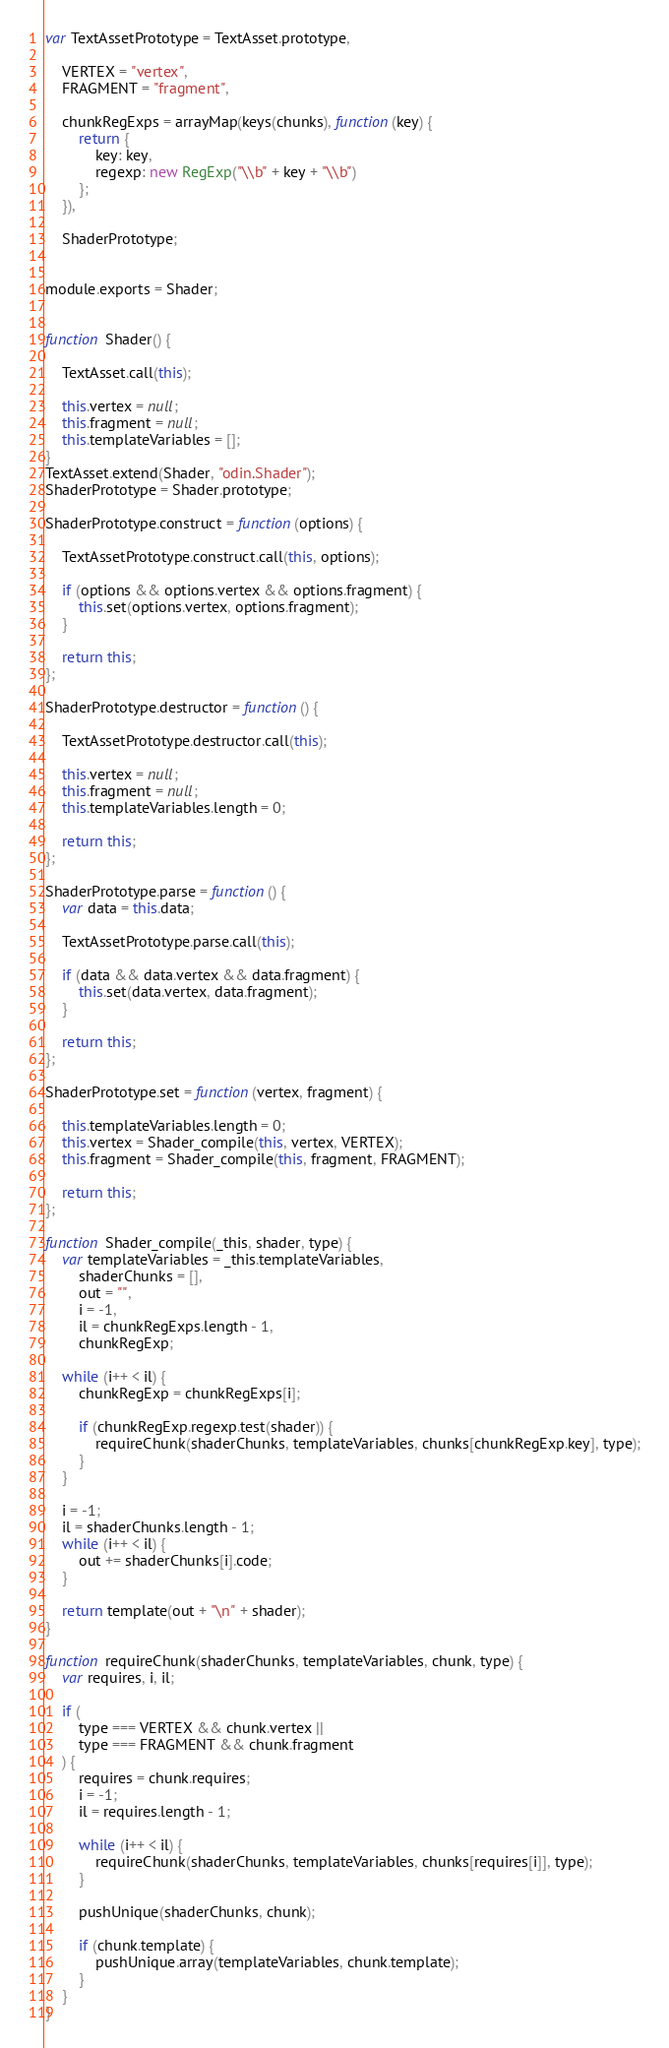Convert code to text. <code><loc_0><loc_0><loc_500><loc_500><_JavaScript_>var TextAssetPrototype = TextAsset.prototype,

    VERTEX = "vertex",
    FRAGMENT = "fragment",

    chunkRegExps = arrayMap(keys(chunks), function(key) {
        return {
            key: key,
            regexp: new RegExp("\\b" + key + "\\b")
        };
    }),

    ShaderPrototype;


module.exports = Shader;


function Shader() {

    TextAsset.call(this);

    this.vertex = null;
    this.fragment = null;
    this.templateVariables = [];
}
TextAsset.extend(Shader, "odin.Shader");
ShaderPrototype = Shader.prototype;

ShaderPrototype.construct = function(options) {

    TextAssetPrototype.construct.call(this, options);

    if (options && options.vertex && options.fragment) {
        this.set(options.vertex, options.fragment);
    }

    return this;
};

ShaderPrototype.destructor = function() {

    TextAssetPrototype.destructor.call(this);

    this.vertex = null;
    this.fragment = null;
    this.templateVariables.length = 0;

    return this;
};

ShaderPrototype.parse = function() {
    var data = this.data;

    TextAssetPrototype.parse.call(this);

    if (data && data.vertex && data.fragment) {
        this.set(data.vertex, data.fragment);
    }

    return this;
};

ShaderPrototype.set = function(vertex, fragment) {

    this.templateVariables.length = 0;
    this.vertex = Shader_compile(this, vertex, VERTEX);
    this.fragment = Shader_compile(this, fragment, FRAGMENT);

    return this;
};

function Shader_compile(_this, shader, type) {
    var templateVariables = _this.templateVariables,
        shaderChunks = [],
        out = "",
        i = -1,
        il = chunkRegExps.length - 1,
        chunkRegExp;

    while (i++ < il) {
        chunkRegExp = chunkRegExps[i];

        if (chunkRegExp.regexp.test(shader)) {
            requireChunk(shaderChunks, templateVariables, chunks[chunkRegExp.key], type);
        }
    }

    i = -1;
    il = shaderChunks.length - 1;
    while (i++ < il) {
        out += shaderChunks[i].code;
    }

    return template(out + "\n" + shader);
}

function requireChunk(shaderChunks, templateVariables, chunk, type) {
    var requires, i, il;

    if (
        type === VERTEX && chunk.vertex ||
        type === FRAGMENT && chunk.fragment
    ) {
        requires = chunk.requires;
        i = -1;
        il = requires.length - 1;

        while (i++ < il) {
            requireChunk(shaderChunks, templateVariables, chunks[requires[i]], type);
        }

        pushUnique(shaderChunks, chunk);

        if (chunk.template) {
            pushUnique.array(templateVariables, chunk.template);
        }
    }
}
</code> 